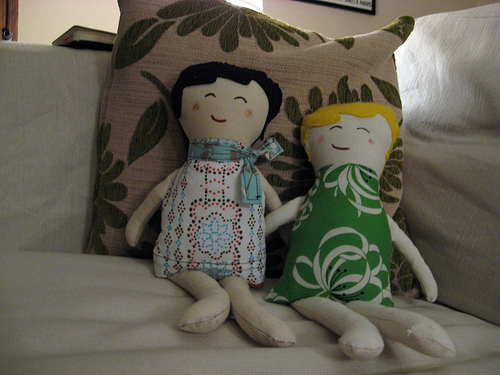<image>
Is the doll to the right of the pillow? No. The doll is not to the right of the pillow. The horizontal positioning shows a different relationship. 